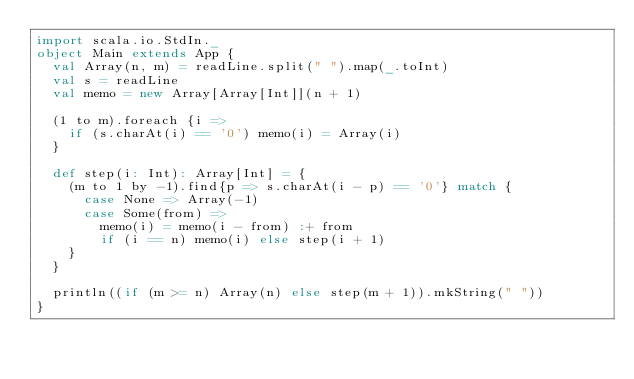<code> <loc_0><loc_0><loc_500><loc_500><_Scala_>import scala.io.StdIn._
object Main extends App {
  val Array(n, m) = readLine.split(" ").map(_.toInt)
  val s = readLine
  val memo = new Array[Array[Int]](n + 1)

  (1 to m).foreach {i =>
    if (s.charAt(i) == '0') memo(i) = Array(i)
  }

  def step(i: Int): Array[Int] = {
    (m to 1 by -1).find{p => s.charAt(i - p) == '0'} match {
      case None => Array(-1)
      case Some(from) =>
        memo(i) = memo(i - from) :+ from
        if (i == n) memo(i) else step(i + 1)
    }
  }

  println((if (m >= n) Array(n) else step(m + 1)).mkString(" "))
}</code> 